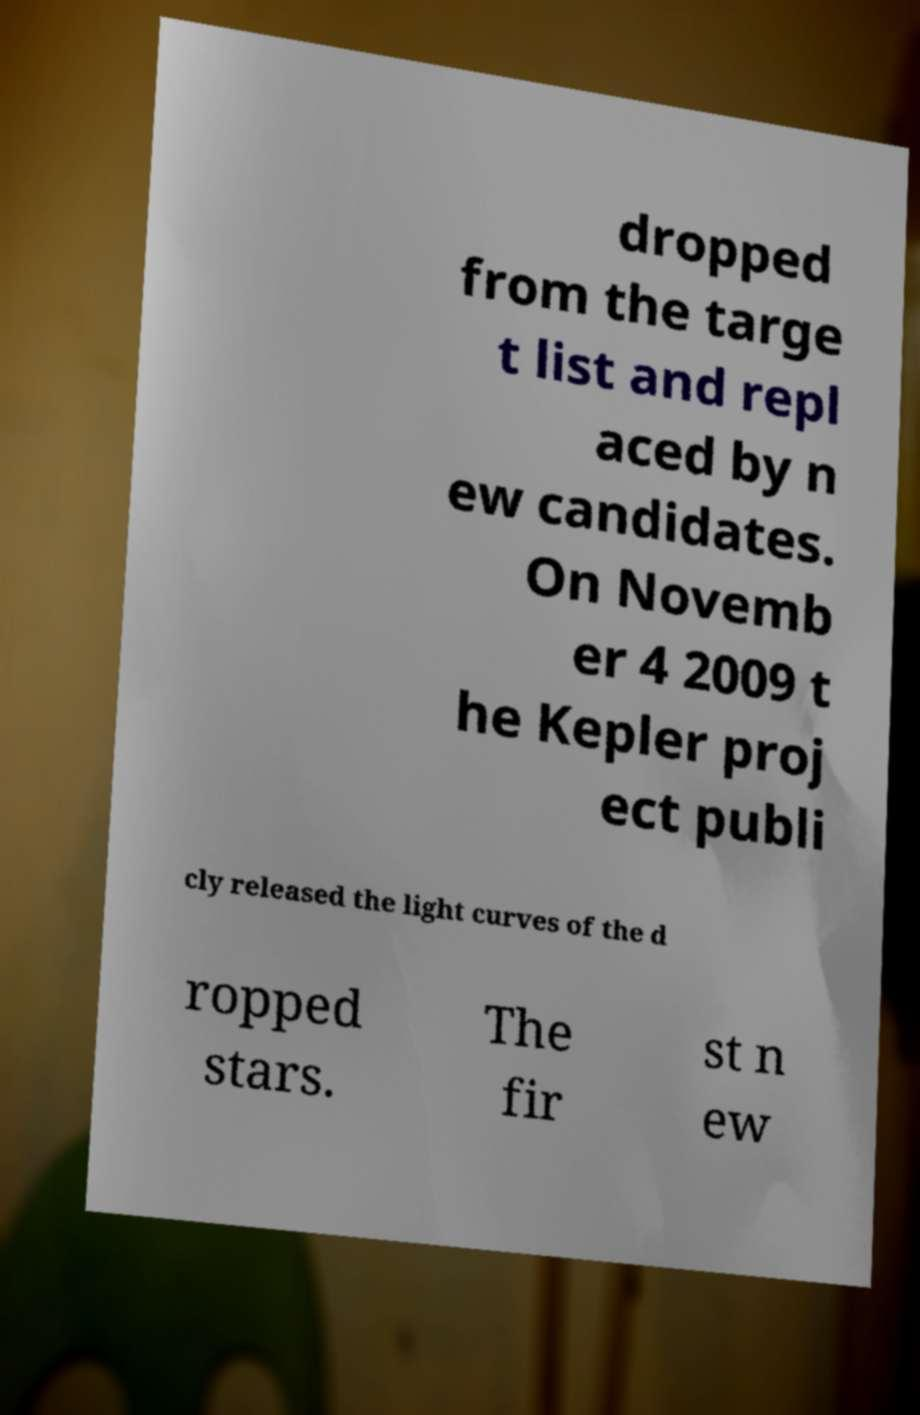Can you read and provide the text displayed in the image?This photo seems to have some interesting text. Can you extract and type it out for me? dropped from the targe t list and repl aced by n ew candidates. On Novemb er 4 2009 t he Kepler proj ect publi cly released the light curves of the d ropped stars. The fir st n ew 